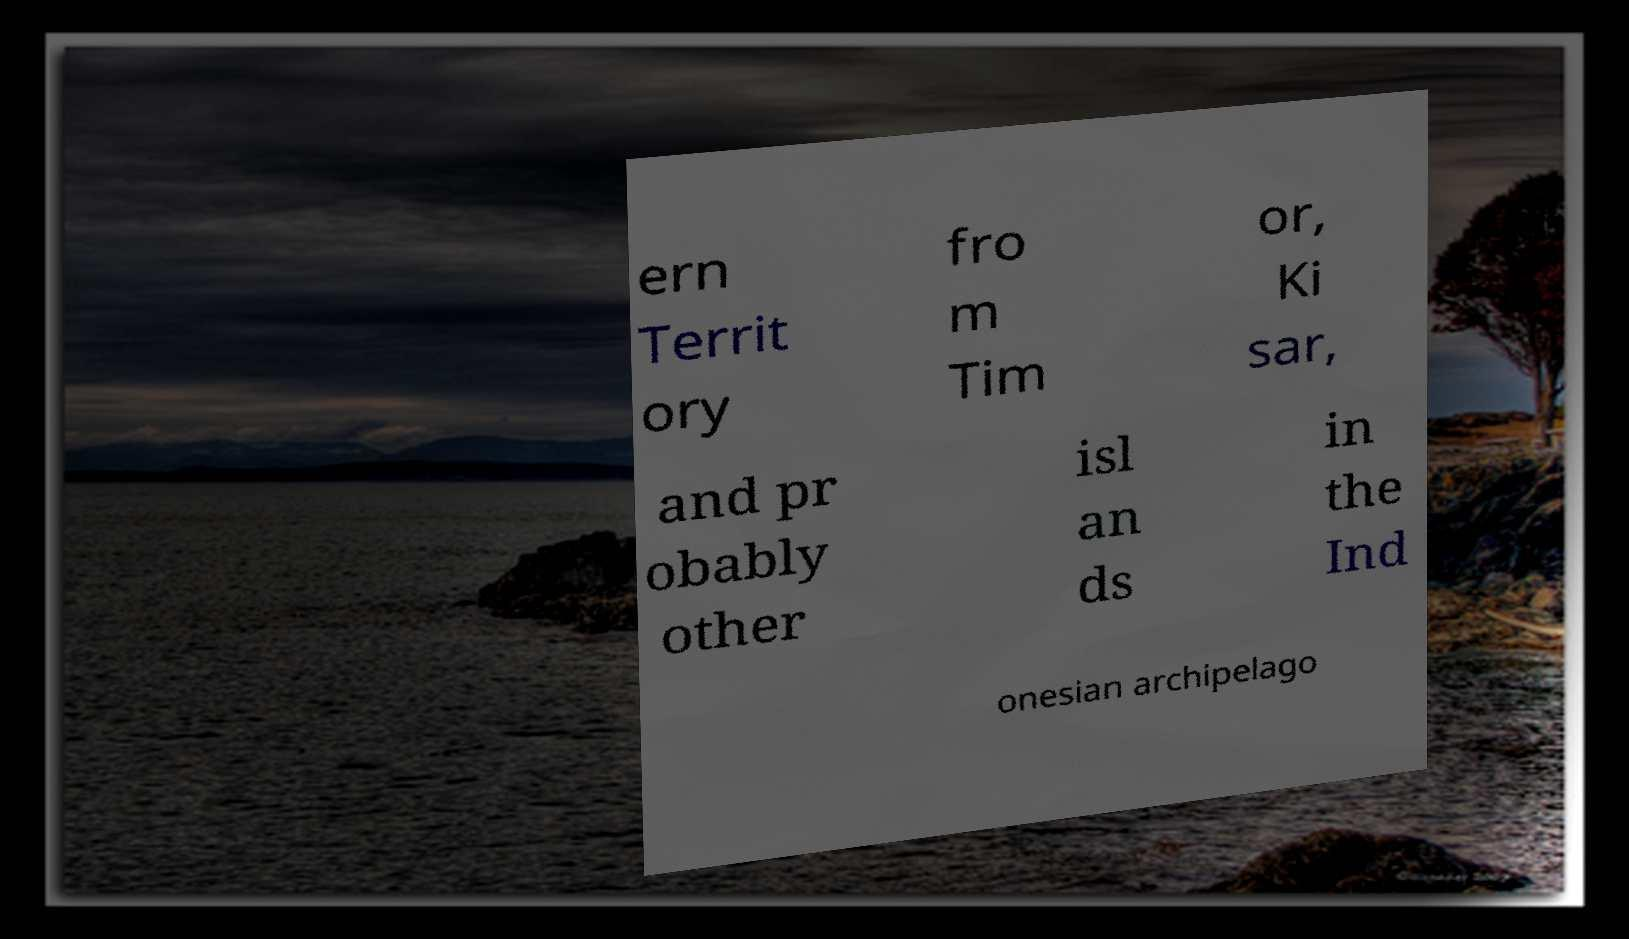I need the written content from this picture converted into text. Can you do that? ern Territ ory fro m Tim or, Ki sar, and pr obably other isl an ds in the Ind onesian archipelago 